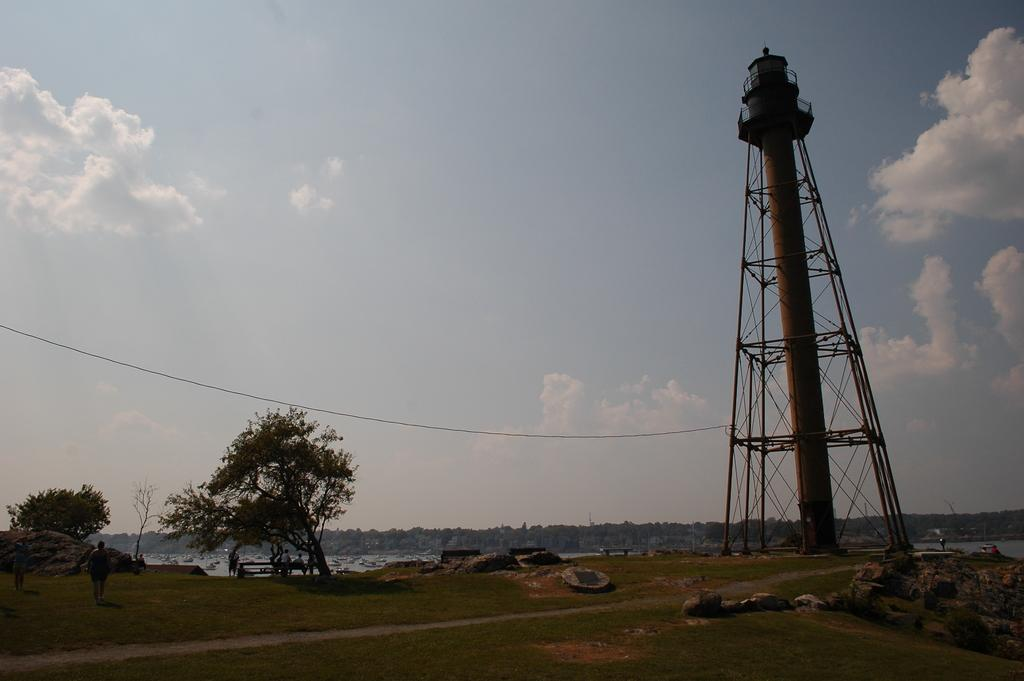What is the main structure in the image? There is a tower in the image. What else can be seen in the image besides the tower? Electric wires, grass, a path, a tree, water, stones, and the sky are visible in the image. What is the condition of the sky in the image? The sky is cloudy in the image. Are there any people present in the image? Yes, there are people in the image. What type of crime is being committed in the image? There is no indication of any crime being committed in the image. Can you tell me how many grains of sand are visible in the image? There is no sand present in the image. 